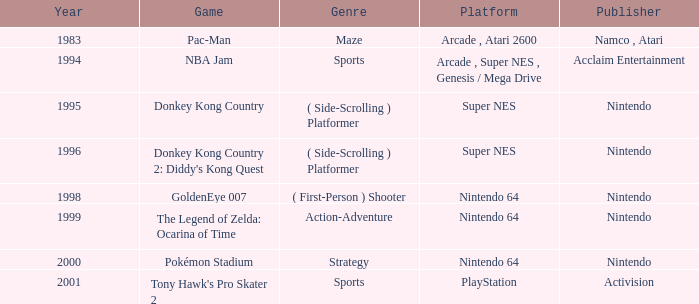What type of game is donkey kong country in terms of genre? ( Side-Scrolling ) Platformer. 